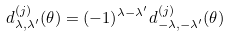Convert formula to latex. <formula><loc_0><loc_0><loc_500><loc_500>d ^ { ( j ) } _ { \lambda , \lambda ^ { \prime } } ( \theta ) = ( - 1 ) ^ { \lambda - \lambda ^ { \prime } } d ^ { ( j ) } _ { - \lambda , - \lambda ^ { \prime } } ( \theta )</formula> 